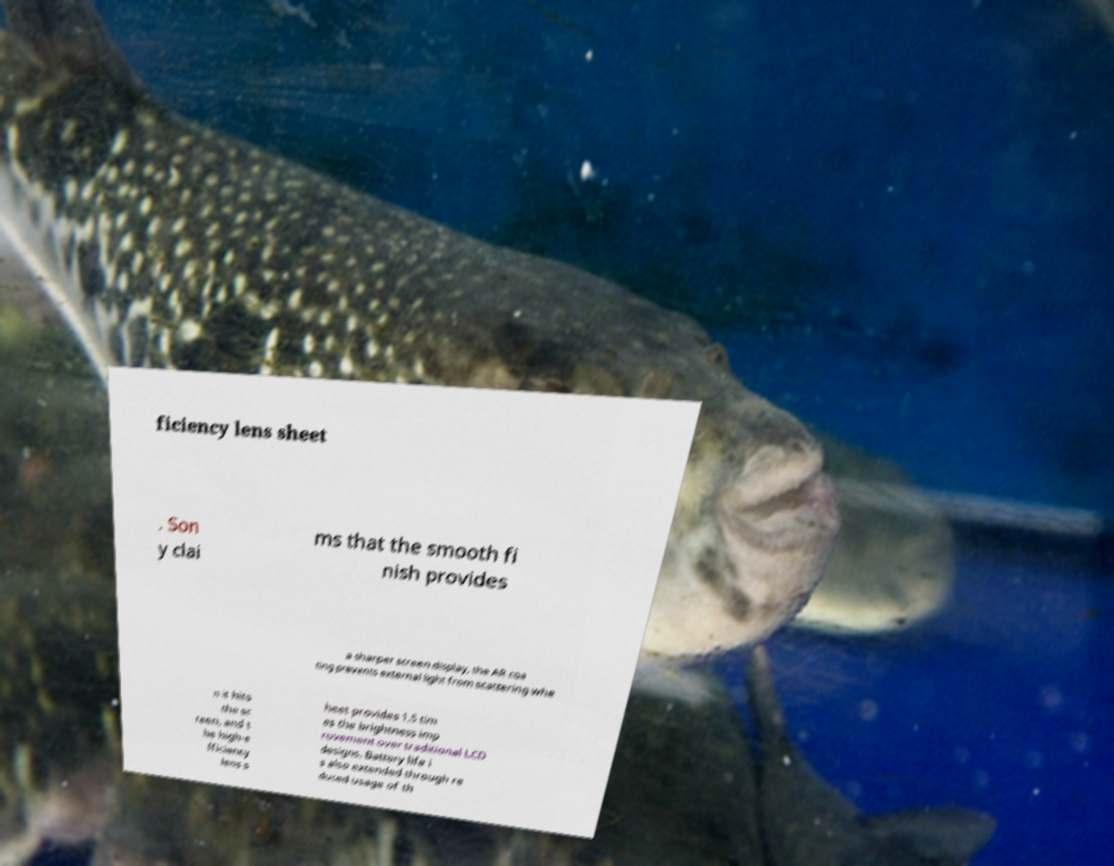Please identify and transcribe the text found in this image. ficiency lens sheet . Son y clai ms that the smooth fi nish provides a sharper screen display, the AR coa ting prevents external light from scattering whe n it hits the sc reen, and t he high-e fficiency lens s heet provides 1.5 tim es the brightness imp rovement over traditional LCD designs. Battery life i s also extended through re duced usage of th 